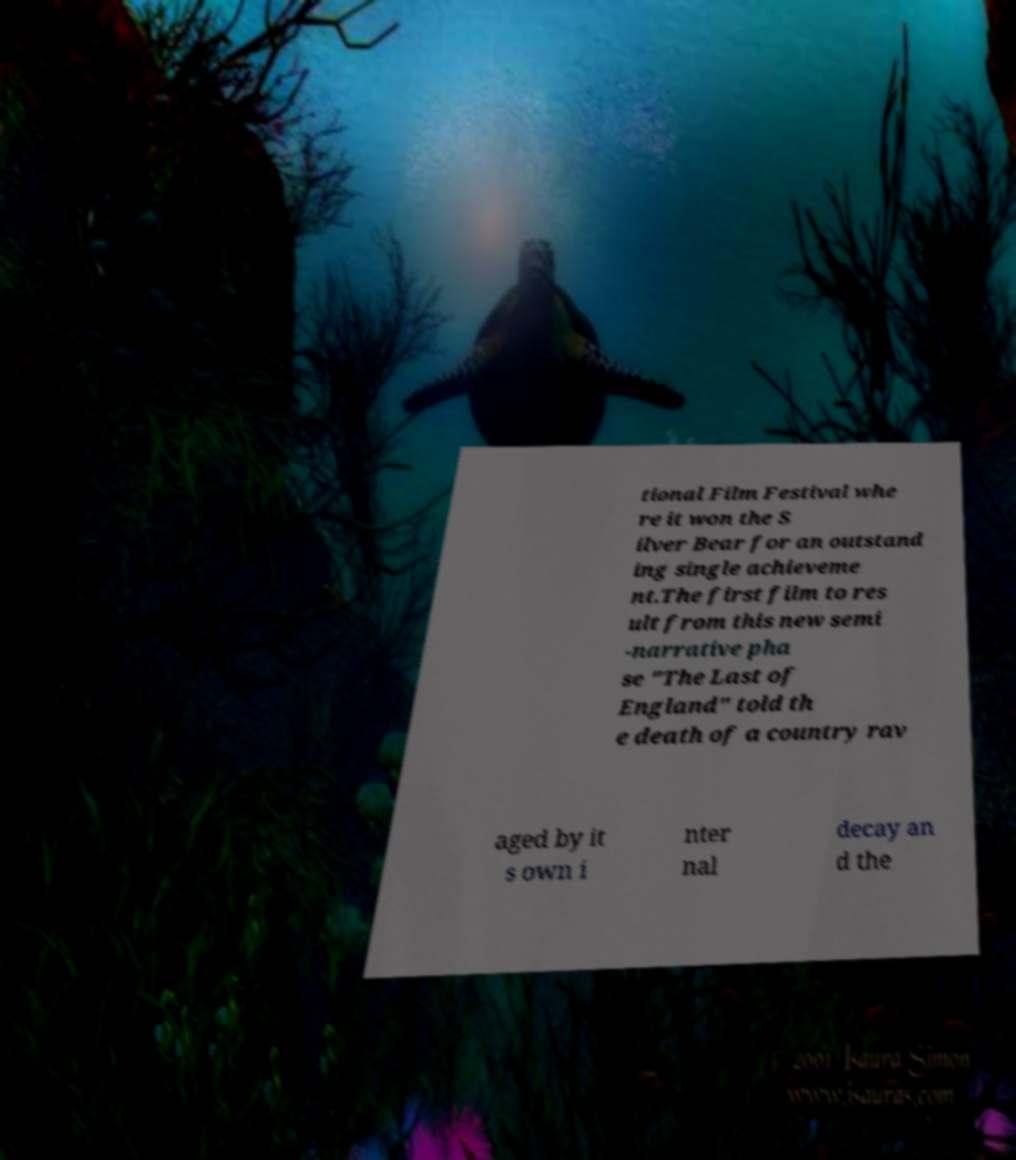For documentation purposes, I need the text within this image transcribed. Could you provide that? tional Film Festival whe re it won the S ilver Bear for an outstand ing single achieveme nt.The first film to res ult from this new semi -narrative pha se "The Last of England" told th e death of a country rav aged by it s own i nter nal decay an d the 